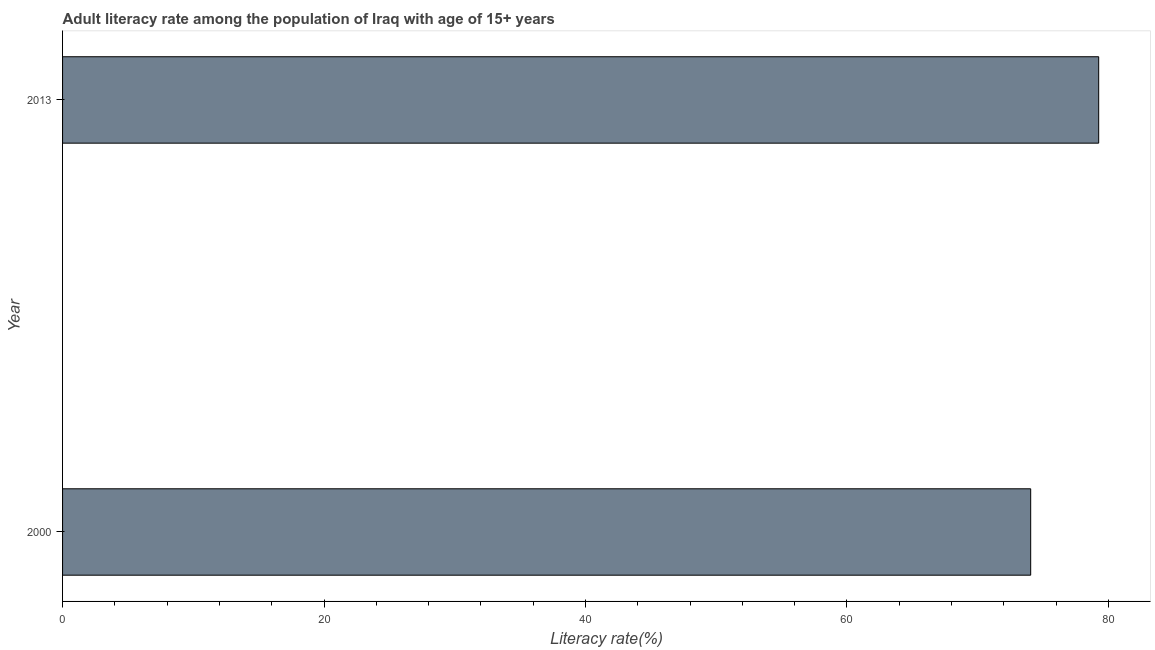Does the graph contain grids?
Your answer should be compact. No. What is the title of the graph?
Your response must be concise. Adult literacy rate among the population of Iraq with age of 15+ years. What is the label or title of the X-axis?
Provide a short and direct response. Literacy rate(%). What is the adult literacy rate in 2013?
Your answer should be very brief. 79.25. Across all years, what is the maximum adult literacy rate?
Offer a terse response. 79.25. Across all years, what is the minimum adult literacy rate?
Keep it short and to the point. 74.05. What is the sum of the adult literacy rate?
Offer a terse response. 153.31. What is the difference between the adult literacy rate in 2000 and 2013?
Your answer should be compact. -5.2. What is the average adult literacy rate per year?
Your answer should be compact. 76.65. What is the median adult literacy rate?
Offer a terse response. 76.65. In how many years, is the adult literacy rate greater than 44 %?
Keep it short and to the point. 2. Do a majority of the years between 2000 and 2013 (inclusive) have adult literacy rate greater than 4 %?
Your response must be concise. Yes. What is the ratio of the adult literacy rate in 2000 to that in 2013?
Your response must be concise. 0.93. In how many years, is the adult literacy rate greater than the average adult literacy rate taken over all years?
Ensure brevity in your answer.  1. How many bars are there?
Offer a terse response. 2. Are all the bars in the graph horizontal?
Your answer should be compact. Yes. What is the Literacy rate(%) of 2000?
Offer a terse response. 74.05. What is the Literacy rate(%) in 2013?
Offer a terse response. 79.25. What is the difference between the Literacy rate(%) in 2000 and 2013?
Provide a succinct answer. -5.2. What is the ratio of the Literacy rate(%) in 2000 to that in 2013?
Your response must be concise. 0.93. 